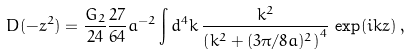<formula> <loc_0><loc_0><loc_500><loc_500>D ( - z ^ { 2 } ) = \frac { G _ { 2 } } { 2 4 } \frac { 2 7 } { 6 4 } a ^ { - 2 } \int d ^ { 4 } k \, \frac { k ^ { 2 } } { \left ( k ^ { 2 } + ( 3 \pi / 8 a ) ^ { 2 } \right ) ^ { 4 } } \, \exp ( i k z ) \, ,</formula> 